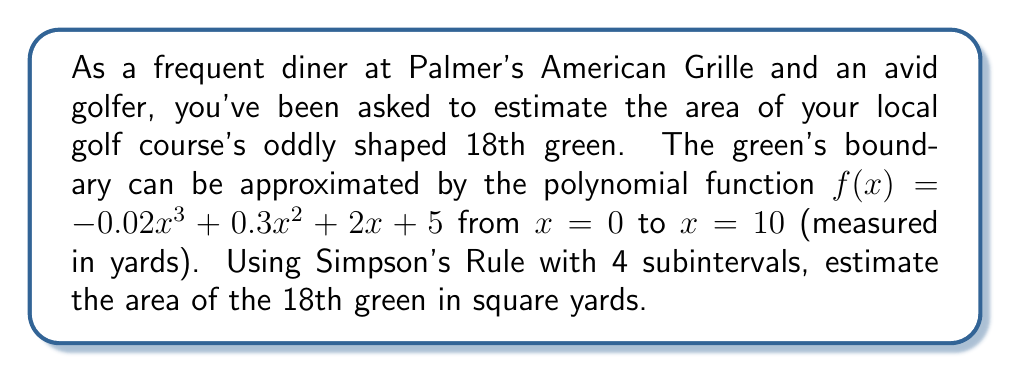Give your solution to this math problem. To estimate the area under the curve $f(x) = -0.02x^3 + 0.3x^2 + 2x + 5$ from $x = 0$ to $x = 10$, we'll use Simpson's Rule with 4 subintervals.

Simpson's Rule formula:
$$\int_a^b f(x)dx \approx \frac{h}{3}[f(x_0) + 4f(x_1) + 2f(x_2) + 4f(x_3) + f(x_4)]$$

Where $h = \frac{b-a}{n}$, $n$ is the number of subintervals, and $x_i$ are equally spaced points.

Step 1: Calculate $h$
$h = \frac{10-0}{4} = 2.5$ yards

Step 2: Determine $x_i$ values
$x_0 = 0$, $x_1 = 2.5$, $x_2 = 5$, $x_3 = 7.5$, $x_4 = 10$

Step 3: Calculate $f(x_i)$ values
$f(x_0) = f(0) = 5$
$f(x_1) = f(2.5) = -0.02(2.5)^3 + 0.3(2.5)^2 + 2(2.5) + 5 = 11.40625$
$f(x_2) = f(5) = -0.02(5)^3 + 0.3(5)^2 + 2(5) + 5 = 20$
$f(x_3) = f(7.5) = -0.02(7.5)^3 + 0.3(7.5)^2 + 2(7.5) + 5 = 28.59375$
$f(x_4) = f(10) = -0.02(10)^3 + 0.3(10)^2 + 2(10) + 5 = 35$

Step 4: Apply Simpson's Rule
$$\text{Area} \approx \frac{2.5}{3}[5 + 4(11.40625) + 2(20) + 4(28.59375) + 35]$$
$$= \frac{2.5}{3}[5 + 45.625 + 40 + 114.375 + 35]$$
$$= \frac{2.5}{3}(240)$$
$$= 200 \text{ square yards}$$
Answer: The estimated area of the 18th green is 200 square yards. 